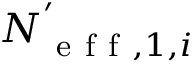<formula> <loc_0><loc_0><loc_500><loc_500>N _ { e f f , 1 , i } ^ { ^ { \prime } }</formula> 